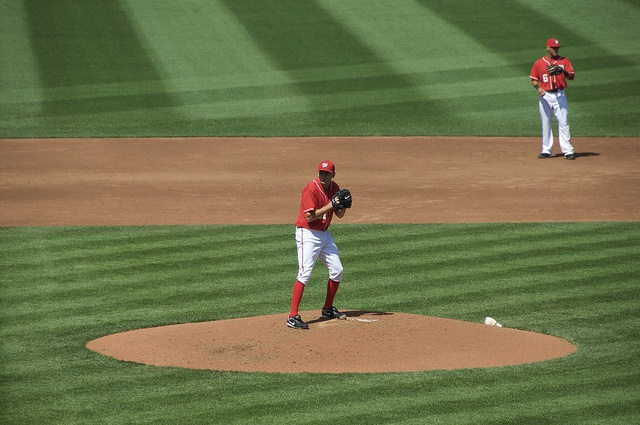Describe the objects in this image and their specific colors. I can see people in darkgreen, white, black, maroon, and gray tones, people in darkgreen, lavender, brown, and gray tones, baseball glove in darkgreen, black, and gray tones, and baseball glove in darkgreen, black, gray, and maroon tones in this image. 